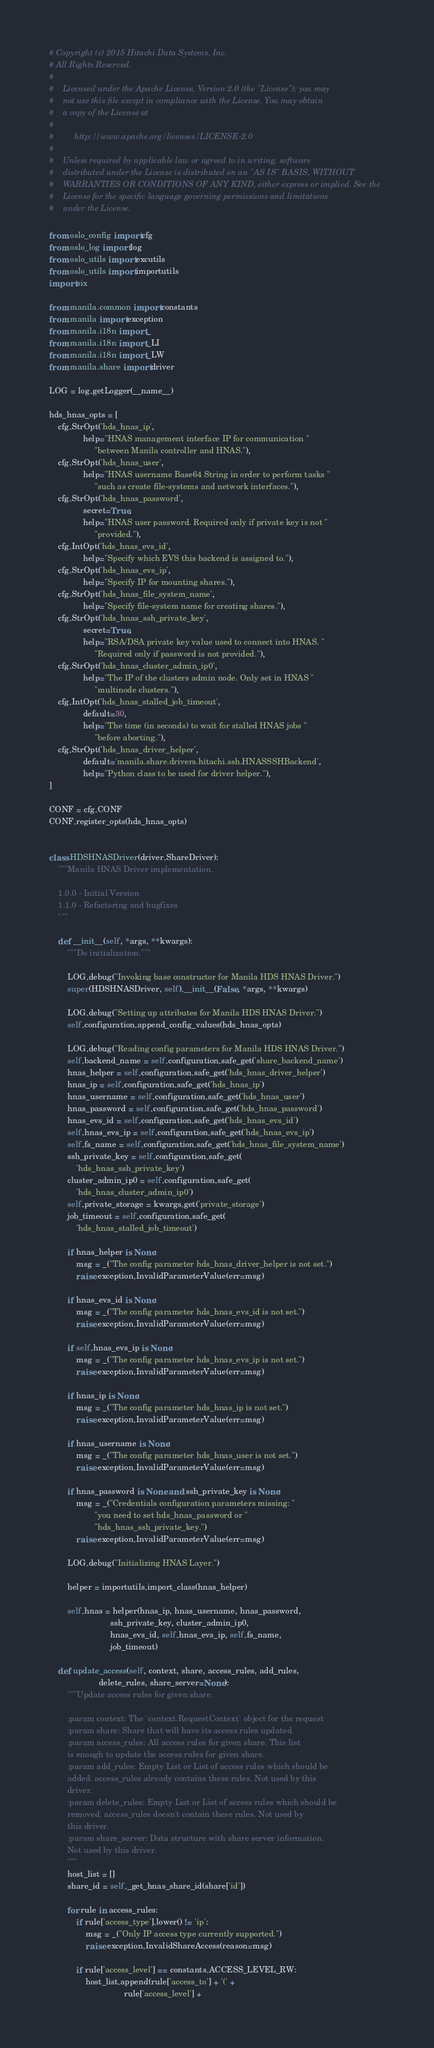Convert code to text. <code><loc_0><loc_0><loc_500><loc_500><_Python_># Copyright (c) 2015 Hitachi Data Systems, Inc.
# All Rights Reserved.
#
#    Licensed under the Apache License, Version 2.0 (the "License"); you may
#    not use this file except in compliance with the License. You may obtain
#    a copy of the License at
#
#         http://www.apache.org/licenses/LICENSE-2.0
#
#    Unless required by applicable law or agreed to in writing, software
#    distributed under the License is distributed on an "AS IS" BASIS, WITHOUT
#    WARRANTIES OR CONDITIONS OF ANY KIND, either express or implied. See the
#    License for the specific language governing permissions and limitations
#    under the License.

from oslo_config import cfg
from oslo_log import log
from oslo_utils import excutils
from oslo_utils import importutils
import six

from manila.common import constants
from manila import exception
from manila.i18n import _
from manila.i18n import _LI
from manila.i18n import _LW
from manila.share import driver

LOG = log.getLogger(__name__)

hds_hnas_opts = [
    cfg.StrOpt('hds_hnas_ip',
               help="HNAS management interface IP for communication "
                    "between Manila controller and HNAS."),
    cfg.StrOpt('hds_hnas_user',
               help="HNAS username Base64 String in order to perform tasks "
                    "such as create file-systems and network interfaces."),
    cfg.StrOpt('hds_hnas_password',
               secret=True,
               help="HNAS user password. Required only if private key is not "
                    "provided."),
    cfg.IntOpt('hds_hnas_evs_id',
               help="Specify which EVS this backend is assigned to."),
    cfg.StrOpt('hds_hnas_evs_ip',
               help="Specify IP for mounting shares."),
    cfg.StrOpt('hds_hnas_file_system_name',
               help="Specify file-system name for creating shares."),
    cfg.StrOpt('hds_hnas_ssh_private_key',
               secret=True,
               help="RSA/DSA private key value used to connect into HNAS. "
                    "Required only if password is not provided."),
    cfg.StrOpt('hds_hnas_cluster_admin_ip0',
               help="The IP of the clusters admin node. Only set in HNAS "
                    "multinode clusters."),
    cfg.IntOpt('hds_hnas_stalled_job_timeout',
               default=30,
               help="The time (in seconds) to wait for stalled HNAS jobs "
                    "before aborting."),
    cfg.StrOpt('hds_hnas_driver_helper',
               default='manila.share.drivers.hitachi.ssh.HNASSSHBackend',
               help="Python class to be used for driver helper."),
]

CONF = cfg.CONF
CONF.register_opts(hds_hnas_opts)


class HDSHNASDriver(driver.ShareDriver):
    """Manila HNAS Driver implementation.

    1.0.0 - Initial Version
    1.1.0 - Refactoring and bugfixes
    """

    def __init__(self, *args, **kwargs):
        """Do initialization."""

        LOG.debug("Invoking base constructor for Manila HDS HNAS Driver.")
        super(HDSHNASDriver, self).__init__(False, *args, **kwargs)

        LOG.debug("Setting up attributes for Manila HDS HNAS Driver.")
        self.configuration.append_config_values(hds_hnas_opts)

        LOG.debug("Reading config parameters for Manila HDS HNAS Driver.")
        self.backend_name = self.configuration.safe_get('share_backend_name')
        hnas_helper = self.configuration.safe_get('hds_hnas_driver_helper')
        hnas_ip = self.configuration.safe_get('hds_hnas_ip')
        hnas_username = self.configuration.safe_get('hds_hnas_user')
        hnas_password = self.configuration.safe_get('hds_hnas_password')
        hnas_evs_id = self.configuration.safe_get('hds_hnas_evs_id')
        self.hnas_evs_ip = self.configuration.safe_get('hds_hnas_evs_ip')
        self.fs_name = self.configuration.safe_get('hds_hnas_file_system_name')
        ssh_private_key = self.configuration.safe_get(
            'hds_hnas_ssh_private_key')
        cluster_admin_ip0 = self.configuration.safe_get(
            'hds_hnas_cluster_admin_ip0')
        self.private_storage = kwargs.get('private_storage')
        job_timeout = self.configuration.safe_get(
            'hds_hnas_stalled_job_timeout')

        if hnas_helper is None:
            msg = _("The config parameter hds_hnas_driver_helper is not set.")
            raise exception.InvalidParameterValue(err=msg)

        if hnas_evs_id is None:
            msg = _("The config parameter hds_hnas_evs_id is not set.")
            raise exception.InvalidParameterValue(err=msg)

        if self.hnas_evs_ip is None:
            msg = _("The config parameter hds_hnas_evs_ip is not set.")
            raise exception.InvalidParameterValue(err=msg)

        if hnas_ip is None:
            msg = _("The config parameter hds_hnas_ip is not set.")
            raise exception.InvalidParameterValue(err=msg)

        if hnas_username is None:
            msg = _("The config parameter hds_hnas_user is not set.")
            raise exception.InvalidParameterValue(err=msg)

        if hnas_password is None and ssh_private_key is None:
            msg = _("Credentials configuration parameters missing: "
                    "you need to set hds_hnas_password or "
                    "hds_hnas_ssh_private_key.")
            raise exception.InvalidParameterValue(err=msg)

        LOG.debug("Initializing HNAS Layer.")

        helper = importutils.import_class(hnas_helper)

        self.hnas = helper(hnas_ip, hnas_username, hnas_password,
                           ssh_private_key, cluster_admin_ip0,
                           hnas_evs_id, self.hnas_evs_ip, self.fs_name,
                           job_timeout)

    def update_access(self, context, share, access_rules, add_rules,
                      delete_rules, share_server=None):
        """Update access rules for given share.

        :param context: The `context.RequestContext` object for the request
        :param share: Share that will have its access rules updated.
        :param access_rules: All access rules for given share. This list
        is enough to update the access rules for given share.
        :param add_rules: Empty List or List of access rules which should be
        added. access_rules already contains these rules. Not used by this
        driver.
        :param delete_rules: Empty List or List of access rules which should be
        removed. access_rules doesn't contain these rules. Not used by
        this driver.
        :param share_server: Data structure with share server information.
        Not used by this driver.
        """
        host_list = []
        share_id = self._get_hnas_share_id(share['id'])

        for rule in access_rules:
            if rule['access_type'].lower() != 'ip':
                msg = _("Only IP access type currently supported.")
                raise exception.InvalidShareAccess(reason=msg)

            if rule['access_level'] == constants.ACCESS_LEVEL_RW:
                host_list.append(rule['access_to'] + '(' +
                                 rule['access_level'] +</code> 